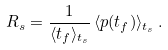<formula> <loc_0><loc_0><loc_500><loc_500>R _ { s } = \frac { 1 } { \langle t _ { f } \rangle _ { t _ { s } } } \, \langle p ( t _ { f } ) \rangle _ { t _ { s } } \, .</formula> 